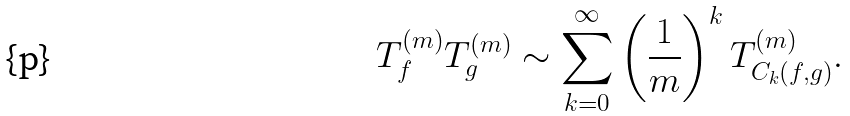<formula> <loc_0><loc_0><loc_500><loc_500>T _ { f } ^ { ( m ) } T _ { g } ^ { ( m ) } \sim \sum _ { k = 0 } ^ { \infty } \left ( \frac { 1 } { m } \right ) ^ { k } T _ { C _ { k } ( f , g ) } ^ { ( m ) } .</formula> 